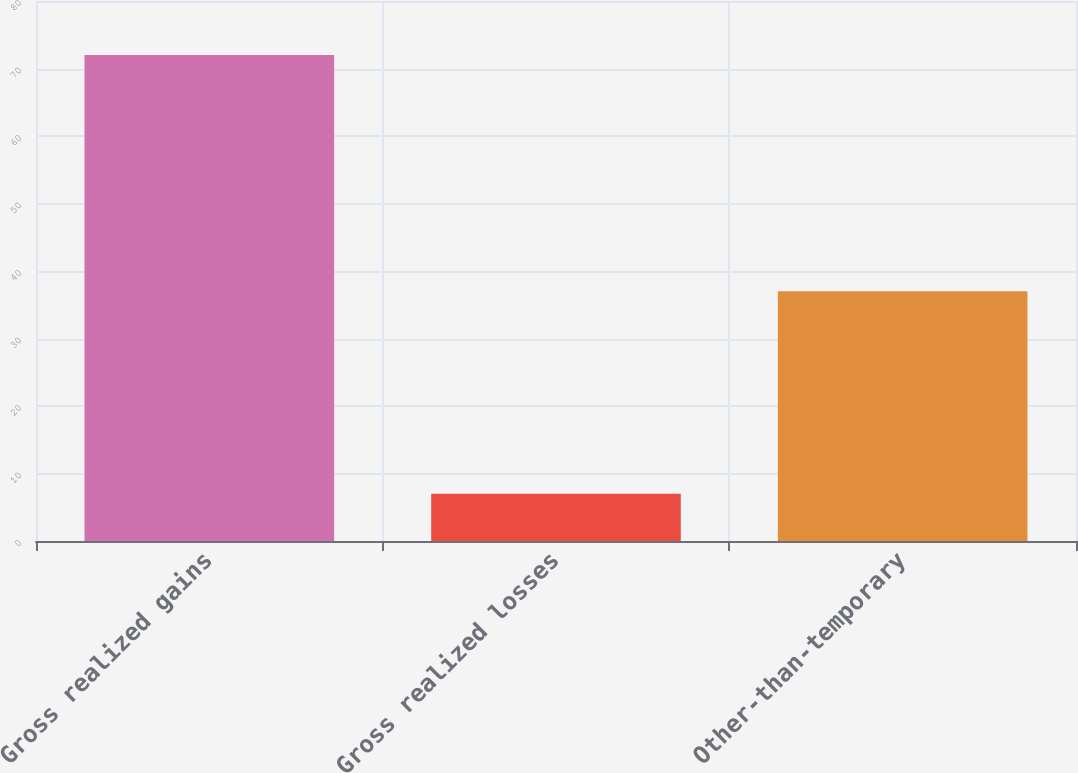Convert chart. <chart><loc_0><loc_0><loc_500><loc_500><bar_chart><fcel>Gross realized gains<fcel>Gross realized losses<fcel>Other-than-temporary<nl><fcel>72<fcel>7<fcel>37<nl></chart> 